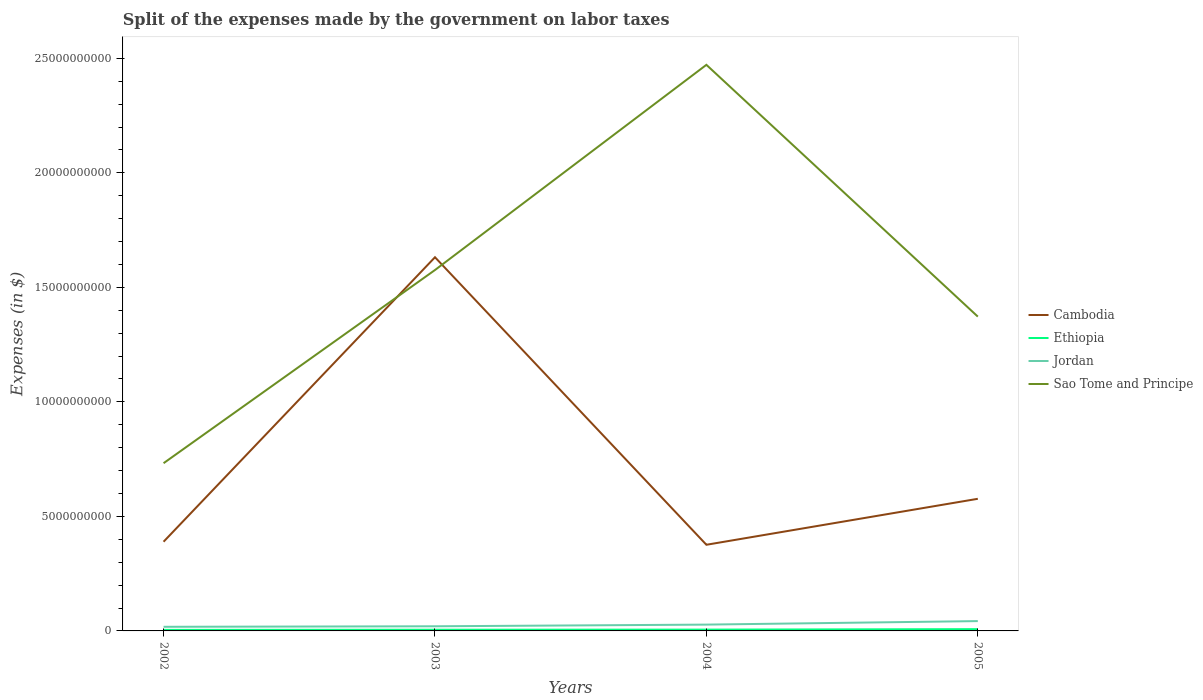Across all years, what is the maximum expenses made by the government on labor taxes in Sao Tome and Principe?
Provide a short and direct response. 7.32e+09. In which year was the expenses made by the government on labor taxes in Jordan maximum?
Provide a short and direct response. 2002. What is the total expenses made by the government on labor taxes in Sao Tome and Principe in the graph?
Offer a terse response. 1.10e+1. What is the difference between the highest and the second highest expenses made by the government on labor taxes in Ethiopia?
Your answer should be very brief. 3.20e+07. What is the difference between the highest and the lowest expenses made by the government on labor taxes in Ethiopia?
Provide a succinct answer. 1. How many lines are there?
Your answer should be compact. 4. How many years are there in the graph?
Your response must be concise. 4. What is the difference between two consecutive major ticks on the Y-axis?
Your answer should be compact. 5.00e+09. Are the values on the major ticks of Y-axis written in scientific E-notation?
Your answer should be very brief. No. Does the graph contain any zero values?
Give a very brief answer. No. How many legend labels are there?
Your response must be concise. 4. How are the legend labels stacked?
Offer a terse response. Vertical. What is the title of the graph?
Keep it short and to the point. Split of the expenses made by the government on labor taxes. What is the label or title of the X-axis?
Your answer should be compact. Years. What is the label or title of the Y-axis?
Give a very brief answer. Expenses (in $). What is the Expenses (in $) of Cambodia in 2002?
Make the answer very short. 3.89e+09. What is the Expenses (in $) of Ethiopia in 2002?
Your answer should be compact. 4.51e+07. What is the Expenses (in $) of Jordan in 2002?
Your response must be concise. 1.80e+08. What is the Expenses (in $) of Sao Tome and Principe in 2002?
Ensure brevity in your answer.  7.32e+09. What is the Expenses (in $) of Cambodia in 2003?
Ensure brevity in your answer.  1.63e+1. What is the Expenses (in $) of Ethiopia in 2003?
Your response must be concise. 5.20e+07. What is the Expenses (in $) in Jordan in 2003?
Offer a terse response. 2.02e+08. What is the Expenses (in $) of Sao Tome and Principe in 2003?
Give a very brief answer. 1.58e+1. What is the Expenses (in $) in Cambodia in 2004?
Give a very brief answer. 3.76e+09. What is the Expenses (in $) of Ethiopia in 2004?
Provide a succinct answer. 5.71e+07. What is the Expenses (in $) in Jordan in 2004?
Ensure brevity in your answer.  2.76e+08. What is the Expenses (in $) of Sao Tome and Principe in 2004?
Ensure brevity in your answer.  2.47e+1. What is the Expenses (in $) in Cambodia in 2005?
Give a very brief answer. 5.77e+09. What is the Expenses (in $) of Ethiopia in 2005?
Ensure brevity in your answer.  7.71e+07. What is the Expenses (in $) of Jordan in 2005?
Provide a short and direct response. 4.29e+08. What is the Expenses (in $) in Sao Tome and Principe in 2005?
Offer a very short reply. 1.37e+1. Across all years, what is the maximum Expenses (in $) in Cambodia?
Your response must be concise. 1.63e+1. Across all years, what is the maximum Expenses (in $) of Ethiopia?
Offer a very short reply. 7.71e+07. Across all years, what is the maximum Expenses (in $) in Jordan?
Offer a terse response. 4.29e+08. Across all years, what is the maximum Expenses (in $) in Sao Tome and Principe?
Keep it short and to the point. 2.47e+1. Across all years, what is the minimum Expenses (in $) of Cambodia?
Provide a short and direct response. 3.76e+09. Across all years, what is the minimum Expenses (in $) in Ethiopia?
Offer a terse response. 4.51e+07. Across all years, what is the minimum Expenses (in $) of Jordan?
Provide a short and direct response. 1.80e+08. Across all years, what is the minimum Expenses (in $) in Sao Tome and Principe?
Provide a short and direct response. 7.32e+09. What is the total Expenses (in $) of Cambodia in the graph?
Your answer should be compact. 2.97e+1. What is the total Expenses (in $) of Ethiopia in the graph?
Your response must be concise. 2.31e+08. What is the total Expenses (in $) of Jordan in the graph?
Give a very brief answer. 1.09e+09. What is the total Expenses (in $) in Sao Tome and Principe in the graph?
Provide a short and direct response. 6.15e+1. What is the difference between the Expenses (in $) of Cambodia in 2002 and that in 2003?
Your response must be concise. -1.24e+1. What is the difference between the Expenses (in $) in Ethiopia in 2002 and that in 2003?
Provide a succinct answer. -6.90e+06. What is the difference between the Expenses (in $) of Jordan in 2002 and that in 2003?
Your answer should be compact. -2.20e+07. What is the difference between the Expenses (in $) in Sao Tome and Principe in 2002 and that in 2003?
Offer a terse response. -8.43e+09. What is the difference between the Expenses (in $) in Cambodia in 2002 and that in 2004?
Make the answer very short. 1.33e+08. What is the difference between the Expenses (in $) of Ethiopia in 2002 and that in 2004?
Give a very brief answer. -1.20e+07. What is the difference between the Expenses (in $) of Jordan in 2002 and that in 2004?
Ensure brevity in your answer.  -9.56e+07. What is the difference between the Expenses (in $) of Sao Tome and Principe in 2002 and that in 2004?
Your answer should be compact. -1.74e+1. What is the difference between the Expenses (in $) in Cambodia in 2002 and that in 2005?
Your response must be concise. -1.87e+09. What is the difference between the Expenses (in $) in Ethiopia in 2002 and that in 2005?
Provide a short and direct response. -3.20e+07. What is the difference between the Expenses (in $) of Jordan in 2002 and that in 2005?
Offer a very short reply. -2.49e+08. What is the difference between the Expenses (in $) in Sao Tome and Principe in 2002 and that in 2005?
Ensure brevity in your answer.  -6.40e+09. What is the difference between the Expenses (in $) in Cambodia in 2003 and that in 2004?
Your response must be concise. 1.26e+1. What is the difference between the Expenses (in $) of Ethiopia in 2003 and that in 2004?
Your answer should be very brief. -5.10e+06. What is the difference between the Expenses (in $) of Jordan in 2003 and that in 2004?
Your answer should be compact. -7.36e+07. What is the difference between the Expenses (in $) in Sao Tome and Principe in 2003 and that in 2004?
Make the answer very short. -8.96e+09. What is the difference between the Expenses (in $) in Cambodia in 2003 and that in 2005?
Provide a succinct answer. 1.05e+1. What is the difference between the Expenses (in $) in Ethiopia in 2003 and that in 2005?
Provide a succinct answer. -2.51e+07. What is the difference between the Expenses (in $) of Jordan in 2003 and that in 2005?
Your answer should be very brief. -2.27e+08. What is the difference between the Expenses (in $) of Sao Tome and Principe in 2003 and that in 2005?
Ensure brevity in your answer.  2.03e+09. What is the difference between the Expenses (in $) of Cambodia in 2004 and that in 2005?
Keep it short and to the point. -2.01e+09. What is the difference between the Expenses (in $) of Ethiopia in 2004 and that in 2005?
Offer a terse response. -2.00e+07. What is the difference between the Expenses (in $) of Jordan in 2004 and that in 2005?
Offer a terse response. -1.53e+08. What is the difference between the Expenses (in $) of Sao Tome and Principe in 2004 and that in 2005?
Provide a short and direct response. 1.10e+1. What is the difference between the Expenses (in $) in Cambodia in 2002 and the Expenses (in $) in Ethiopia in 2003?
Your answer should be compact. 3.84e+09. What is the difference between the Expenses (in $) of Cambodia in 2002 and the Expenses (in $) of Jordan in 2003?
Keep it short and to the point. 3.69e+09. What is the difference between the Expenses (in $) in Cambodia in 2002 and the Expenses (in $) in Sao Tome and Principe in 2003?
Give a very brief answer. -1.19e+1. What is the difference between the Expenses (in $) of Ethiopia in 2002 and the Expenses (in $) of Jordan in 2003?
Make the answer very short. -1.57e+08. What is the difference between the Expenses (in $) of Ethiopia in 2002 and the Expenses (in $) of Sao Tome and Principe in 2003?
Offer a very short reply. -1.57e+1. What is the difference between the Expenses (in $) in Jordan in 2002 and the Expenses (in $) in Sao Tome and Principe in 2003?
Offer a terse response. -1.56e+1. What is the difference between the Expenses (in $) in Cambodia in 2002 and the Expenses (in $) in Ethiopia in 2004?
Provide a short and direct response. 3.84e+09. What is the difference between the Expenses (in $) of Cambodia in 2002 and the Expenses (in $) of Jordan in 2004?
Your answer should be compact. 3.62e+09. What is the difference between the Expenses (in $) of Cambodia in 2002 and the Expenses (in $) of Sao Tome and Principe in 2004?
Offer a very short reply. -2.08e+1. What is the difference between the Expenses (in $) in Ethiopia in 2002 and the Expenses (in $) in Jordan in 2004?
Your response must be concise. -2.31e+08. What is the difference between the Expenses (in $) of Ethiopia in 2002 and the Expenses (in $) of Sao Tome and Principe in 2004?
Provide a succinct answer. -2.47e+1. What is the difference between the Expenses (in $) in Jordan in 2002 and the Expenses (in $) in Sao Tome and Principe in 2004?
Your response must be concise. -2.45e+1. What is the difference between the Expenses (in $) of Cambodia in 2002 and the Expenses (in $) of Ethiopia in 2005?
Your answer should be very brief. 3.82e+09. What is the difference between the Expenses (in $) in Cambodia in 2002 and the Expenses (in $) in Jordan in 2005?
Offer a terse response. 3.47e+09. What is the difference between the Expenses (in $) in Cambodia in 2002 and the Expenses (in $) in Sao Tome and Principe in 2005?
Your answer should be very brief. -9.83e+09. What is the difference between the Expenses (in $) in Ethiopia in 2002 and the Expenses (in $) in Jordan in 2005?
Offer a very short reply. -3.84e+08. What is the difference between the Expenses (in $) of Ethiopia in 2002 and the Expenses (in $) of Sao Tome and Principe in 2005?
Provide a succinct answer. -1.37e+1. What is the difference between the Expenses (in $) in Jordan in 2002 and the Expenses (in $) in Sao Tome and Principe in 2005?
Your response must be concise. -1.35e+1. What is the difference between the Expenses (in $) of Cambodia in 2003 and the Expenses (in $) of Ethiopia in 2004?
Your answer should be compact. 1.63e+1. What is the difference between the Expenses (in $) in Cambodia in 2003 and the Expenses (in $) in Jordan in 2004?
Ensure brevity in your answer.  1.60e+1. What is the difference between the Expenses (in $) of Cambodia in 2003 and the Expenses (in $) of Sao Tome and Principe in 2004?
Your answer should be very brief. -8.40e+09. What is the difference between the Expenses (in $) in Ethiopia in 2003 and the Expenses (in $) in Jordan in 2004?
Offer a terse response. -2.24e+08. What is the difference between the Expenses (in $) of Ethiopia in 2003 and the Expenses (in $) of Sao Tome and Principe in 2004?
Provide a succinct answer. -2.47e+1. What is the difference between the Expenses (in $) of Jordan in 2003 and the Expenses (in $) of Sao Tome and Principe in 2004?
Your response must be concise. -2.45e+1. What is the difference between the Expenses (in $) of Cambodia in 2003 and the Expenses (in $) of Ethiopia in 2005?
Offer a very short reply. 1.62e+1. What is the difference between the Expenses (in $) of Cambodia in 2003 and the Expenses (in $) of Jordan in 2005?
Provide a short and direct response. 1.59e+1. What is the difference between the Expenses (in $) of Cambodia in 2003 and the Expenses (in $) of Sao Tome and Principe in 2005?
Offer a very short reply. 2.59e+09. What is the difference between the Expenses (in $) of Ethiopia in 2003 and the Expenses (in $) of Jordan in 2005?
Provide a short and direct response. -3.77e+08. What is the difference between the Expenses (in $) of Ethiopia in 2003 and the Expenses (in $) of Sao Tome and Principe in 2005?
Give a very brief answer. -1.37e+1. What is the difference between the Expenses (in $) in Jordan in 2003 and the Expenses (in $) in Sao Tome and Principe in 2005?
Make the answer very short. -1.35e+1. What is the difference between the Expenses (in $) of Cambodia in 2004 and the Expenses (in $) of Ethiopia in 2005?
Ensure brevity in your answer.  3.68e+09. What is the difference between the Expenses (in $) in Cambodia in 2004 and the Expenses (in $) in Jordan in 2005?
Offer a very short reply. 3.33e+09. What is the difference between the Expenses (in $) in Cambodia in 2004 and the Expenses (in $) in Sao Tome and Principe in 2005?
Your answer should be very brief. -9.96e+09. What is the difference between the Expenses (in $) of Ethiopia in 2004 and the Expenses (in $) of Jordan in 2005?
Keep it short and to the point. -3.72e+08. What is the difference between the Expenses (in $) of Ethiopia in 2004 and the Expenses (in $) of Sao Tome and Principe in 2005?
Provide a succinct answer. -1.37e+1. What is the difference between the Expenses (in $) of Jordan in 2004 and the Expenses (in $) of Sao Tome and Principe in 2005?
Your answer should be very brief. -1.34e+1. What is the average Expenses (in $) of Cambodia per year?
Offer a terse response. 7.43e+09. What is the average Expenses (in $) of Ethiopia per year?
Ensure brevity in your answer.  5.78e+07. What is the average Expenses (in $) in Jordan per year?
Provide a short and direct response. 2.72e+08. What is the average Expenses (in $) of Sao Tome and Principe per year?
Make the answer very short. 1.54e+1. In the year 2002, what is the difference between the Expenses (in $) in Cambodia and Expenses (in $) in Ethiopia?
Offer a terse response. 3.85e+09. In the year 2002, what is the difference between the Expenses (in $) in Cambodia and Expenses (in $) in Jordan?
Give a very brief answer. 3.71e+09. In the year 2002, what is the difference between the Expenses (in $) in Cambodia and Expenses (in $) in Sao Tome and Principe?
Provide a succinct answer. -3.43e+09. In the year 2002, what is the difference between the Expenses (in $) of Ethiopia and Expenses (in $) of Jordan?
Your answer should be compact. -1.35e+08. In the year 2002, what is the difference between the Expenses (in $) in Ethiopia and Expenses (in $) in Sao Tome and Principe?
Your response must be concise. -7.28e+09. In the year 2002, what is the difference between the Expenses (in $) of Jordan and Expenses (in $) of Sao Tome and Principe?
Provide a short and direct response. -7.14e+09. In the year 2003, what is the difference between the Expenses (in $) in Cambodia and Expenses (in $) in Ethiopia?
Provide a short and direct response. 1.63e+1. In the year 2003, what is the difference between the Expenses (in $) in Cambodia and Expenses (in $) in Jordan?
Your response must be concise. 1.61e+1. In the year 2003, what is the difference between the Expenses (in $) in Cambodia and Expenses (in $) in Sao Tome and Principe?
Provide a succinct answer. 5.58e+08. In the year 2003, what is the difference between the Expenses (in $) in Ethiopia and Expenses (in $) in Jordan?
Keep it short and to the point. -1.50e+08. In the year 2003, what is the difference between the Expenses (in $) in Ethiopia and Expenses (in $) in Sao Tome and Principe?
Keep it short and to the point. -1.57e+1. In the year 2003, what is the difference between the Expenses (in $) in Jordan and Expenses (in $) in Sao Tome and Principe?
Give a very brief answer. -1.56e+1. In the year 2004, what is the difference between the Expenses (in $) of Cambodia and Expenses (in $) of Ethiopia?
Your answer should be compact. 3.70e+09. In the year 2004, what is the difference between the Expenses (in $) in Cambodia and Expenses (in $) in Jordan?
Offer a very short reply. 3.49e+09. In the year 2004, what is the difference between the Expenses (in $) of Cambodia and Expenses (in $) of Sao Tome and Principe?
Offer a very short reply. -2.10e+1. In the year 2004, what is the difference between the Expenses (in $) in Ethiopia and Expenses (in $) in Jordan?
Keep it short and to the point. -2.19e+08. In the year 2004, what is the difference between the Expenses (in $) of Ethiopia and Expenses (in $) of Sao Tome and Principe?
Provide a succinct answer. -2.47e+1. In the year 2004, what is the difference between the Expenses (in $) of Jordan and Expenses (in $) of Sao Tome and Principe?
Provide a succinct answer. -2.44e+1. In the year 2005, what is the difference between the Expenses (in $) in Cambodia and Expenses (in $) in Ethiopia?
Your answer should be compact. 5.69e+09. In the year 2005, what is the difference between the Expenses (in $) of Cambodia and Expenses (in $) of Jordan?
Make the answer very short. 5.34e+09. In the year 2005, what is the difference between the Expenses (in $) in Cambodia and Expenses (in $) in Sao Tome and Principe?
Give a very brief answer. -7.95e+09. In the year 2005, what is the difference between the Expenses (in $) in Ethiopia and Expenses (in $) in Jordan?
Provide a short and direct response. -3.52e+08. In the year 2005, what is the difference between the Expenses (in $) in Ethiopia and Expenses (in $) in Sao Tome and Principe?
Your answer should be very brief. -1.36e+1. In the year 2005, what is the difference between the Expenses (in $) in Jordan and Expenses (in $) in Sao Tome and Principe?
Your answer should be compact. -1.33e+1. What is the ratio of the Expenses (in $) in Cambodia in 2002 to that in 2003?
Your answer should be very brief. 0.24. What is the ratio of the Expenses (in $) in Ethiopia in 2002 to that in 2003?
Your answer should be very brief. 0.87. What is the ratio of the Expenses (in $) of Jordan in 2002 to that in 2003?
Make the answer very short. 0.89. What is the ratio of the Expenses (in $) of Sao Tome and Principe in 2002 to that in 2003?
Your answer should be compact. 0.46. What is the ratio of the Expenses (in $) of Cambodia in 2002 to that in 2004?
Your response must be concise. 1.04. What is the ratio of the Expenses (in $) in Ethiopia in 2002 to that in 2004?
Your answer should be compact. 0.79. What is the ratio of the Expenses (in $) of Jordan in 2002 to that in 2004?
Offer a very short reply. 0.65. What is the ratio of the Expenses (in $) of Sao Tome and Principe in 2002 to that in 2004?
Make the answer very short. 0.3. What is the ratio of the Expenses (in $) of Cambodia in 2002 to that in 2005?
Your response must be concise. 0.68. What is the ratio of the Expenses (in $) in Ethiopia in 2002 to that in 2005?
Make the answer very short. 0.58. What is the ratio of the Expenses (in $) in Jordan in 2002 to that in 2005?
Offer a very short reply. 0.42. What is the ratio of the Expenses (in $) in Sao Tome and Principe in 2002 to that in 2005?
Keep it short and to the point. 0.53. What is the ratio of the Expenses (in $) of Cambodia in 2003 to that in 2004?
Your response must be concise. 4.34. What is the ratio of the Expenses (in $) in Ethiopia in 2003 to that in 2004?
Provide a short and direct response. 0.91. What is the ratio of the Expenses (in $) in Jordan in 2003 to that in 2004?
Make the answer very short. 0.73. What is the ratio of the Expenses (in $) in Sao Tome and Principe in 2003 to that in 2004?
Your answer should be very brief. 0.64. What is the ratio of the Expenses (in $) in Cambodia in 2003 to that in 2005?
Give a very brief answer. 2.83. What is the ratio of the Expenses (in $) in Ethiopia in 2003 to that in 2005?
Your answer should be very brief. 0.67. What is the ratio of the Expenses (in $) of Jordan in 2003 to that in 2005?
Offer a very short reply. 0.47. What is the ratio of the Expenses (in $) of Sao Tome and Principe in 2003 to that in 2005?
Provide a succinct answer. 1.15. What is the ratio of the Expenses (in $) in Cambodia in 2004 to that in 2005?
Keep it short and to the point. 0.65. What is the ratio of the Expenses (in $) in Ethiopia in 2004 to that in 2005?
Ensure brevity in your answer.  0.74. What is the ratio of the Expenses (in $) in Jordan in 2004 to that in 2005?
Your answer should be compact. 0.64. What is the ratio of the Expenses (in $) in Sao Tome and Principe in 2004 to that in 2005?
Your answer should be very brief. 1.8. What is the difference between the highest and the second highest Expenses (in $) in Cambodia?
Your answer should be compact. 1.05e+1. What is the difference between the highest and the second highest Expenses (in $) of Jordan?
Your answer should be compact. 1.53e+08. What is the difference between the highest and the second highest Expenses (in $) in Sao Tome and Principe?
Make the answer very short. 8.96e+09. What is the difference between the highest and the lowest Expenses (in $) of Cambodia?
Ensure brevity in your answer.  1.26e+1. What is the difference between the highest and the lowest Expenses (in $) in Ethiopia?
Provide a succinct answer. 3.20e+07. What is the difference between the highest and the lowest Expenses (in $) in Jordan?
Offer a terse response. 2.49e+08. What is the difference between the highest and the lowest Expenses (in $) of Sao Tome and Principe?
Offer a very short reply. 1.74e+1. 